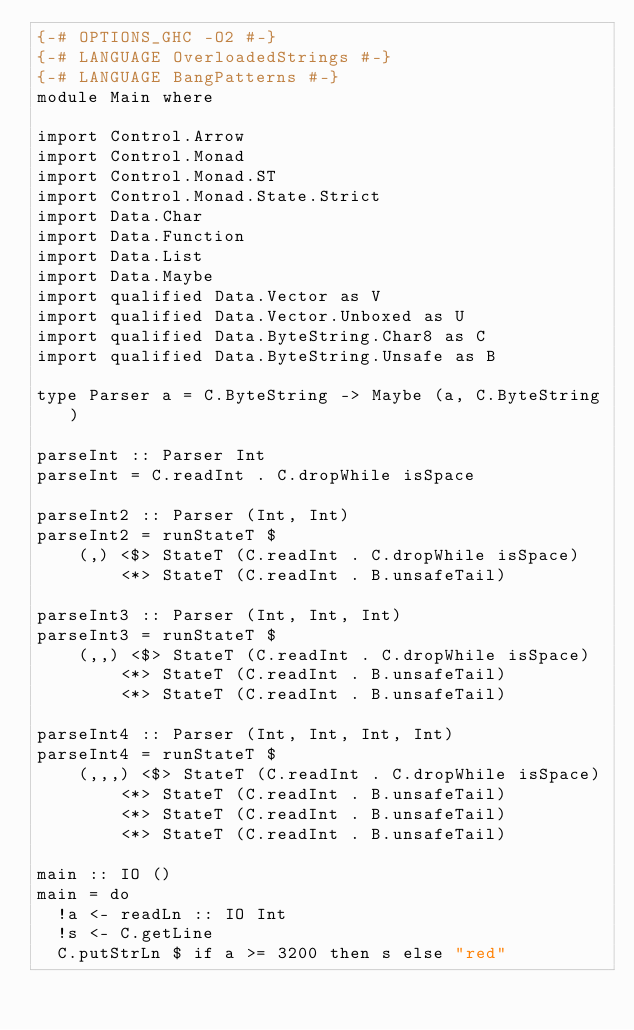<code> <loc_0><loc_0><loc_500><loc_500><_Haskell_>{-# OPTIONS_GHC -O2 #-}
{-# LANGUAGE OverloadedStrings #-}
{-# LANGUAGE BangPatterns #-}
module Main where

import Control.Arrow
import Control.Monad
import Control.Monad.ST
import Control.Monad.State.Strict
import Data.Char
import Data.Function
import Data.List
import Data.Maybe
import qualified Data.Vector as V
import qualified Data.Vector.Unboxed as U
import qualified Data.ByteString.Char8 as C
import qualified Data.ByteString.Unsafe as B

type Parser a = C.ByteString -> Maybe (a, C.ByteString)

parseInt :: Parser Int
parseInt = C.readInt . C.dropWhile isSpace

parseInt2 :: Parser (Int, Int)
parseInt2 = runStateT $
    (,) <$> StateT (C.readInt . C.dropWhile isSpace)
        <*> StateT (C.readInt . B.unsafeTail)
 
parseInt3 :: Parser (Int, Int, Int)
parseInt3 = runStateT $
    (,,) <$> StateT (C.readInt . C.dropWhile isSpace)
        <*> StateT (C.readInt . B.unsafeTail)
        <*> StateT (C.readInt . B.unsafeTail)
 
parseInt4 :: Parser (Int, Int, Int, Int)
parseInt4 = runStateT $
    (,,,) <$> StateT (C.readInt . C.dropWhile isSpace)
        <*> StateT (C.readInt . B.unsafeTail)
        <*> StateT (C.readInt . B.unsafeTail)
        <*> StateT (C.readInt . B.unsafeTail)

main :: IO ()
main = do
  !a <- readLn :: IO Int
  !s <- C.getLine
  C.putStrLn $ if a >= 3200 then s else "red"
</code> 